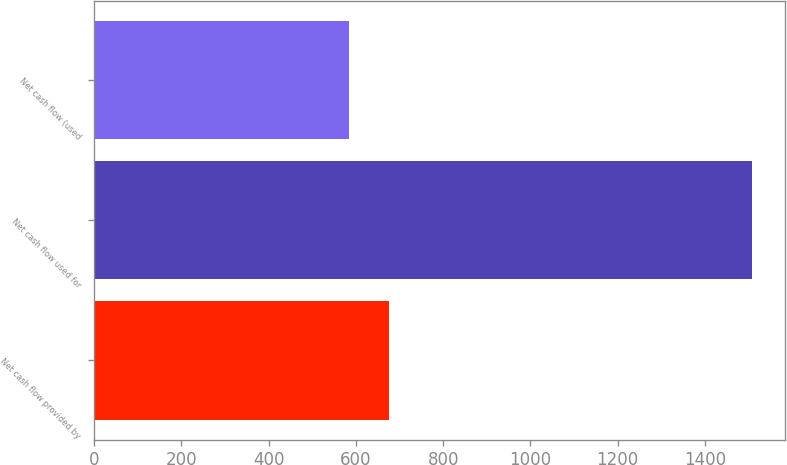Convert chart to OTSL. <chart><loc_0><loc_0><loc_500><loc_500><bar_chart><fcel>Net cash flow provided by<fcel>Net cash flow used for<fcel>Net cash flow (used<nl><fcel>676.45<fcel>1507.6<fcel>584.1<nl></chart> 